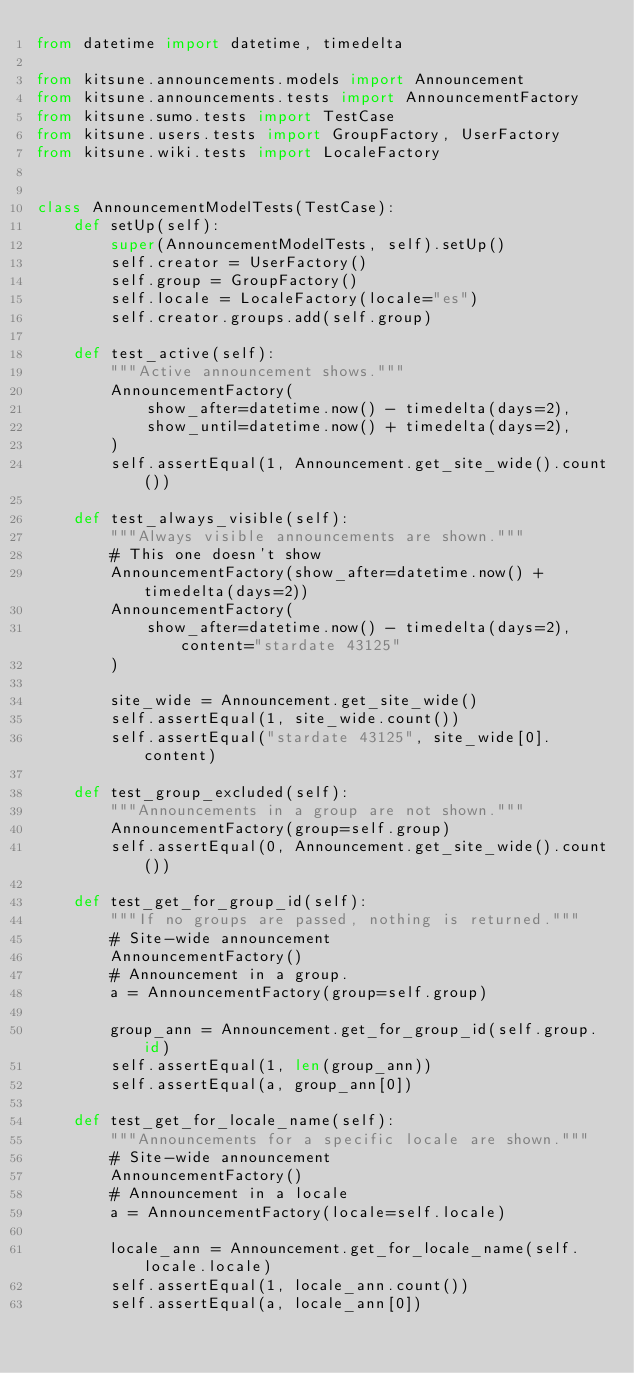<code> <loc_0><loc_0><loc_500><loc_500><_Python_>from datetime import datetime, timedelta

from kitsune.announcements.models import Announcement
from kitsune.announcements.tests import AnnouncementFactory
from kitsune.sumo.tests import TestCase
from kitsune.users.tests import GroupFactory, UserFactory
from kitsune.wiki.tests import LocaleFactory


class AnnouncementModelTests(TestCase):
    def setUp(self):
        super(AnnouncementModelTests, self).setUp()
        self.creator = UserFactory()
        self.group = GroupFactory()
        self.locale = LocaleFactory(locale="es")
        self.creator.groups.add(self.group)

    def test_active(self):
        """Active announcement shows."""
        AnnouncementFactory(
            show_after=datetime.now() - timedelta(days=2),
            show_until=datetime.now() + timedelta(days=2),
        )
        self.assertEqual(1, Announcement.get_site_wide().count())

    def test_always_visible(self):
        """Always visible announcements are shown."""
        # This one doesn't show
        AnnouncementFactory(show_after=datetime.now() + timedelta(days=2))
        AnnouncementFactory(
            show_after=datetime.now() - timedelta(days=2), content="stardate 43125"
        )

        site_wide = Announcement.get_site_wide()
        self.assertEqual(1, site_wide.count())
        self.assertEqual("stardate 43125", site_wide[0].content)

    def test_group_excluded(self):
        """Announcements in a group are not shown."""
        AnnouncementFactory(group=self.group)
        self.assertEqual(0, Announcement.get_site_wide().count())

    def test_get_for_group_id(self):
        """If no groups are passed, nothing is returned."""
        # Site-wide announcement
        AnnouncementFactory()
        # Announcement in a group.
        a = AnnouncementFactory(group=self.group)

        group_ann = Announcement.get_for_group_id(self.group.id)
        self.assertEqual(1, len(group_ann))
        self.assertEqual(a, group_ann[0])

    def test_get_for_locale_name(self):
        """Announcements for a specific locale are shown."""
        # Site-wide announcement
        AnnouncementFactory()
        # Announcement in a locale
        a = AnnouncementFactory(locale=self.locale)

        locale_ann = Announcement.get_for_locale_name(self.locale.locale)
        self.assertEqual(1, locale_ann.count())
        self.assertEqual(a, locale_ann[0])
</code> 